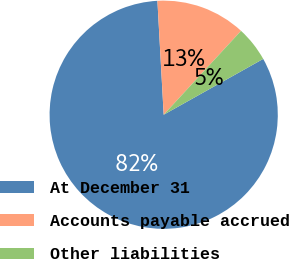Convert chart. <chart><loc_0><loc_0><loc_500><loc_500><pie_chart><fcel>At December 31<fcel>Accounts payable accrued<fcel>Other liabilities<nl><fcel>82.26%<fcel>12.73%<fcel>5.01%<nl></chart> 